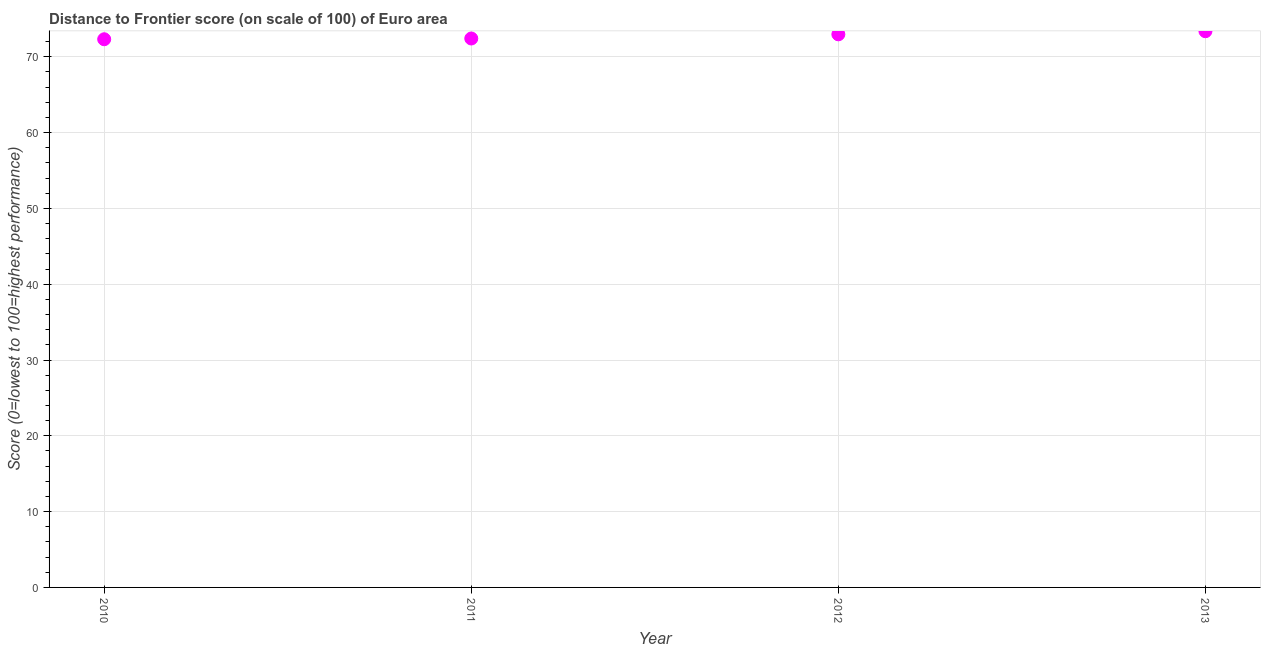What is the distance to frontier score in 2011?
Ensure brevity in your answer.  72.42. Across all years, what is the maximum distance to frontier score?
Provide a short and direct response. 73.38. Across all years, what is the minimum distance to frontier score?
Make the answer very short. 72.32. What is the sum of the distance to frontier score?
Your answer should be compact. 291.08. What is the difference between the distance to frontier score in 2010 and 2013?
Your answer should be very brief. -1.06. What is the average distance to frontier score per year?
Keep it short and to the point. 72.77. What is the median distance to frontier score?
Give a very brief answer. 72.69. What is the ratio of the distance to frontier score in 2011 to that in 2012?
Offer a terse response. 0.99. Is the difference between the distance to frontier score in 2010 and 2011 greater than the difference between any two years?
Provide a short and direct response. No. What is the difference between the highest and the second highest distance to frontier score?
Provide a short and direct response. 0.41. Is the sum of the distance to frontier score in 2011 and 2012 greater than the maximum distance to frontier score across all years?
Ensure brevity in your answer.  Yes. What is the difference between the highest and the lowest distance to frontier score?
Your answer should be compact. 1.06. In how many years, is the distance to frontier score greater than the average distance to frontier score taken over all years?
Keep it short and to the point. 2. Does the distance to frontier score monotonically increase over the years?
Offer a terse response. Yes. Are the values on the major ticks of Y-axis written in scientific E-notation?
Offer a very short reply. No. What is the title of the graph?
Your answer should be compact. Distance to Frontier score (on scale of 100) of Euro area. What is the label or title of the X-axis?
Ensure brevity in your answer.  Year. What is the label or title of the Y-axis?
Give a very brief answer. Score (0=lowest to 100=highest performance). What is the Score (0=lowest to 100=highest performance) in 2010?
Provide a succinct answer. 72.32. What is the Score (0=lowest to 100=highest performance) in 2011?
Your answer should be very brief. 72.42. What is the Score (0=lowest to 100=highest performance) in 2012?
Your answer should be very brief. 72.97. What is the Score (0=lowest to 100=highest performance) in 2013?
Give a very brief answer. 73.38. What is the difference between the Score (0=lowest to 100=highest performance) in 2010 and 2011?
Ensure brevity in your answer.  -0.1. What is the difference between the Score (0=lowest to 100=highest performance) in 2010 and 2012?
Your answer should be compact. -0.65. What is the difference between the Score (0=lowest to 100=highest performance) in 2010 and 2013?
Provide a short and direct response. -1.06. What is the difference between the Score (0=lowest to 100=highest performance) in 2011 and 2012?
Offer a very short reply. -0.55. What is the difference between the Score (0=lowest to 100=highest performance) in 2011 and 2013?
Your answer should be compact. -0.96. What is the difference between the Score (0=lowest to 100=highest performance) in 2012 and 2013?
Your response must be concise. -0.41. What is the ratio of the Score (0=lowest to 100=highest performance) in 2010 to that in 2011?
Your response must be concise. 1. What is the ratio of the Score (0=lowest to 100=highest performance) in 2010 to that in 2012?
Offer a terse response. 0.99. What is the ratio of the Score (0=lowest to 100=highest performance) in 2011 to that in 2012?
Your response must be concise. 0.99. 